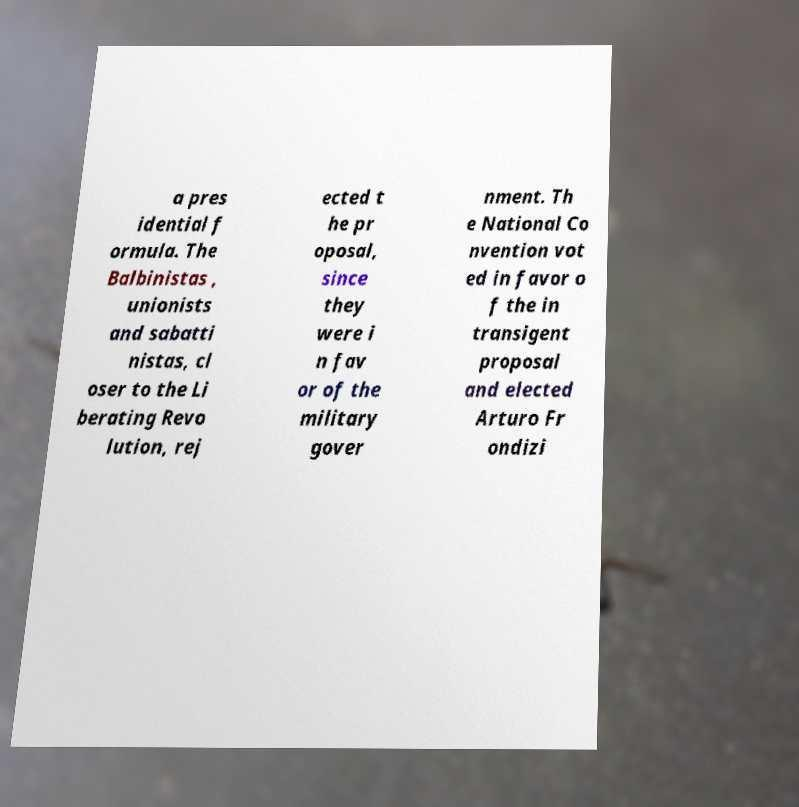For documentation purposes, I need the text within this image transcribed. Could you provide that? a pres idential f ormula. The Balbinistas , unionists and sabatti nistas, cl oser to the Li berating Revo lution, rej ected t he pr oposal, since they were i n fav or of the military gover nment. Th e National Co nvention vot ed in favor o f the in transigent proposal and elected Arturo Fr ondizi 